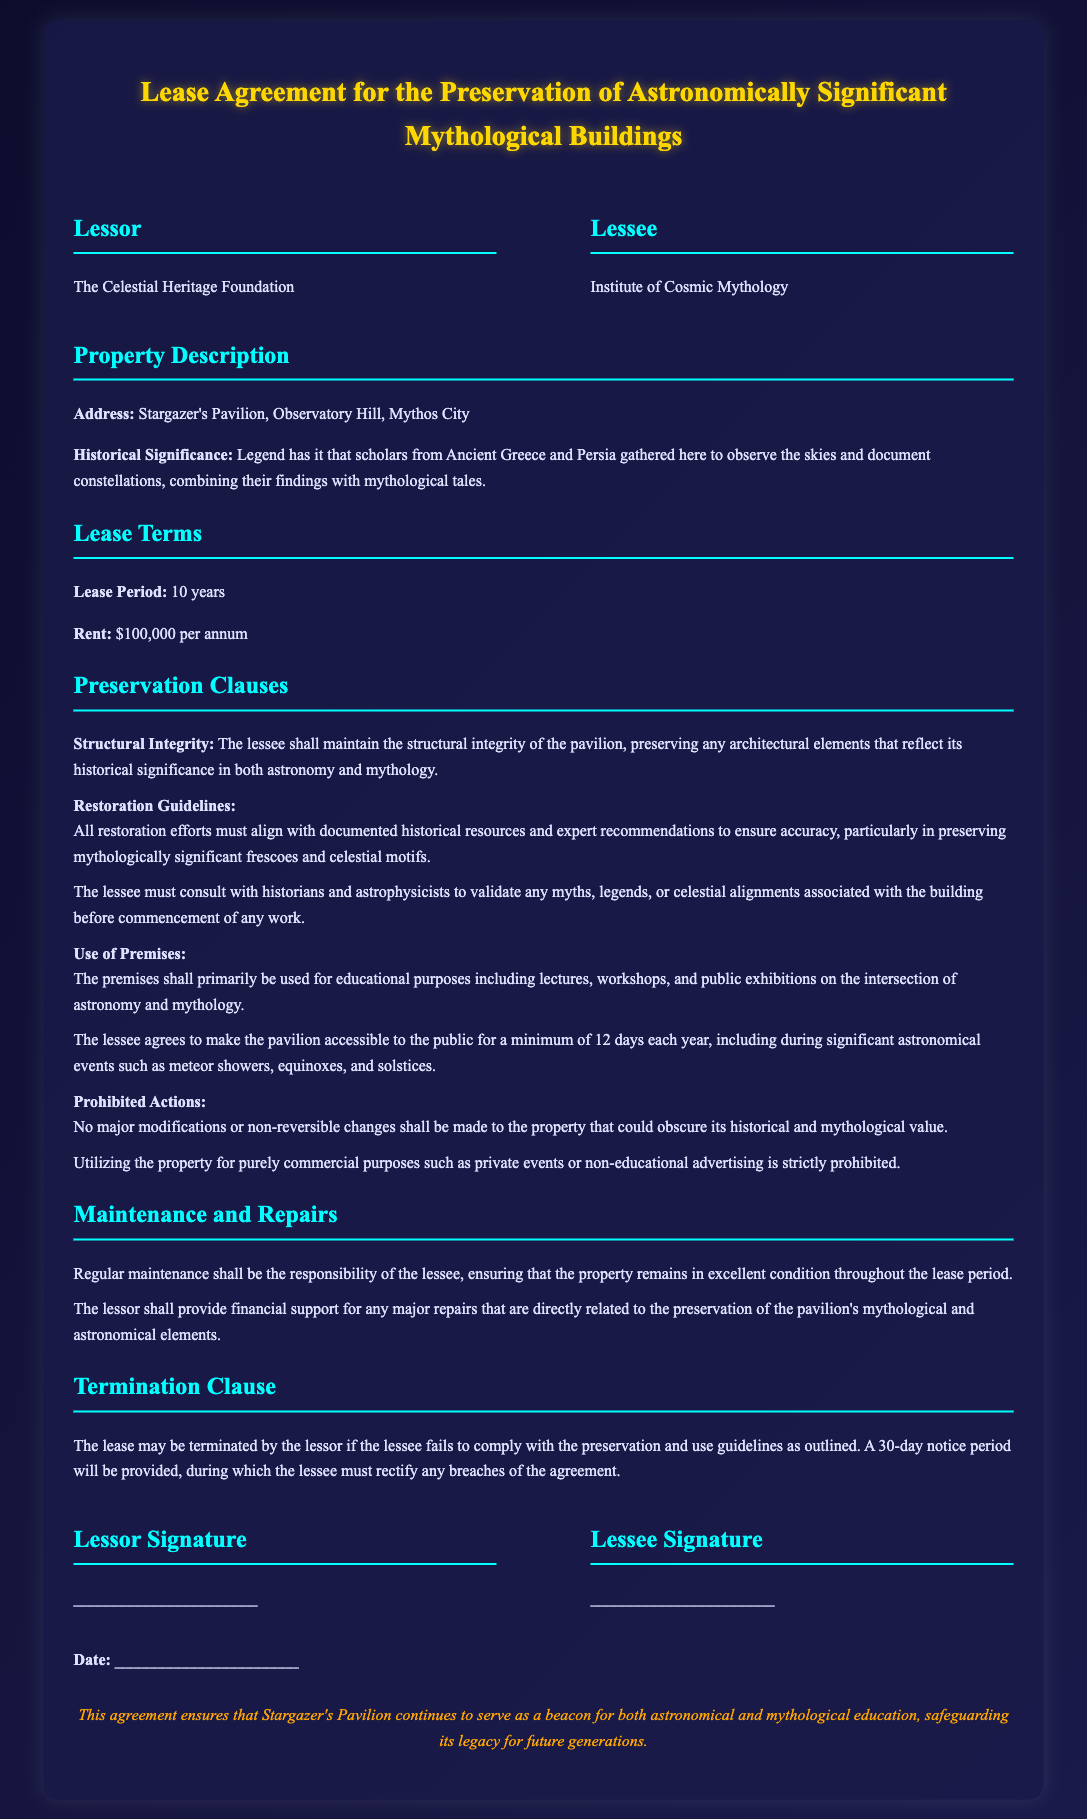What is the lease period? The lease period is specified in the document under Lease Terms, indicating the duration of the agreement.
Answer: 10 years Who is the lessor? The lessor is identified at the beginning of the document, indicating the entity providing the property for lease.
Answer: The Celestial Heritage Foundation What is the annual rent? The annual rent amount is detailed under Lease Terms, indicating the financial obligation of the lessee.
Answer: $100,000 What type of events must the pavilion be accessible for? The document specifies that the lessee must allow public access during certain significant events, indicating its educational purpose.
Answer: Significant astronomical events What must restoration efforts align with? The document states that restoration efforts need to adhere to specific guidelines to maintain the historical integrity of the property.
Answer: Documented historical resources What is prohibited regarding modifications to the property? The document outlines specific restrictions on altering the property to preserve its value, indicating the importance of its historical context.
Answer: Major modifications What financial support does the lessor provide? The document describes the lessor's role in supporting certain maintenance activities, indicating the collaborative effort in preservation.
Answer: Major repairs What is the notice period for lease termination? The lease termination clause specifies the duration the lessee has to rectify breaches before termination can occur.
Answer: 30 days What type of organization is the lessee? The lessee's identity is revealed in the opening section, indicating the nature of its alignment with the property's purpose.
Answer: Institute of Cosmic Mythology 